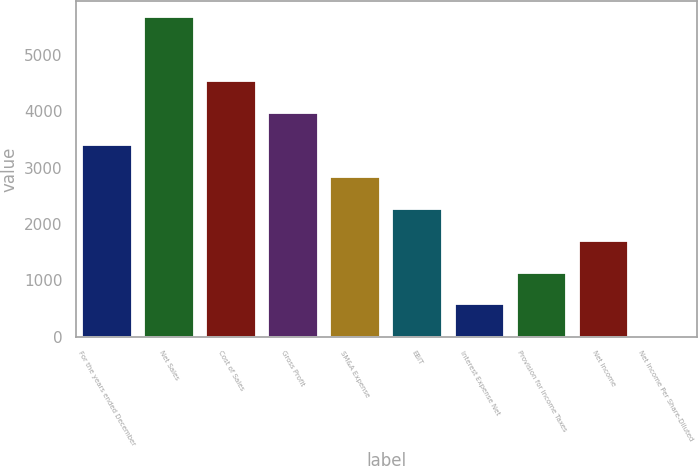Convert chart. <chart><loc_0><loc_0><loc_500><loc_500><bar_chart><fcel>For the years ended December<fcel>Net Sales<fcel>Cost of Sales<fcel>Gross Profit<fcel>SM&A Expense<fcel>EBIT<fcel>Interest Expense Net<fcel>Provision for Income Taxes<fcel>Net Income<fcel>Net Income Per Share-Diluted<nl><fcel>3403.49<fcel>5671<fcel>4537.25<fcel>3970.37<fcel>2836.61<fcel>2269.73<fcel>569.09<fcel>1135.97<fcel>1702.85<fcel>2.21<nl></chart> 